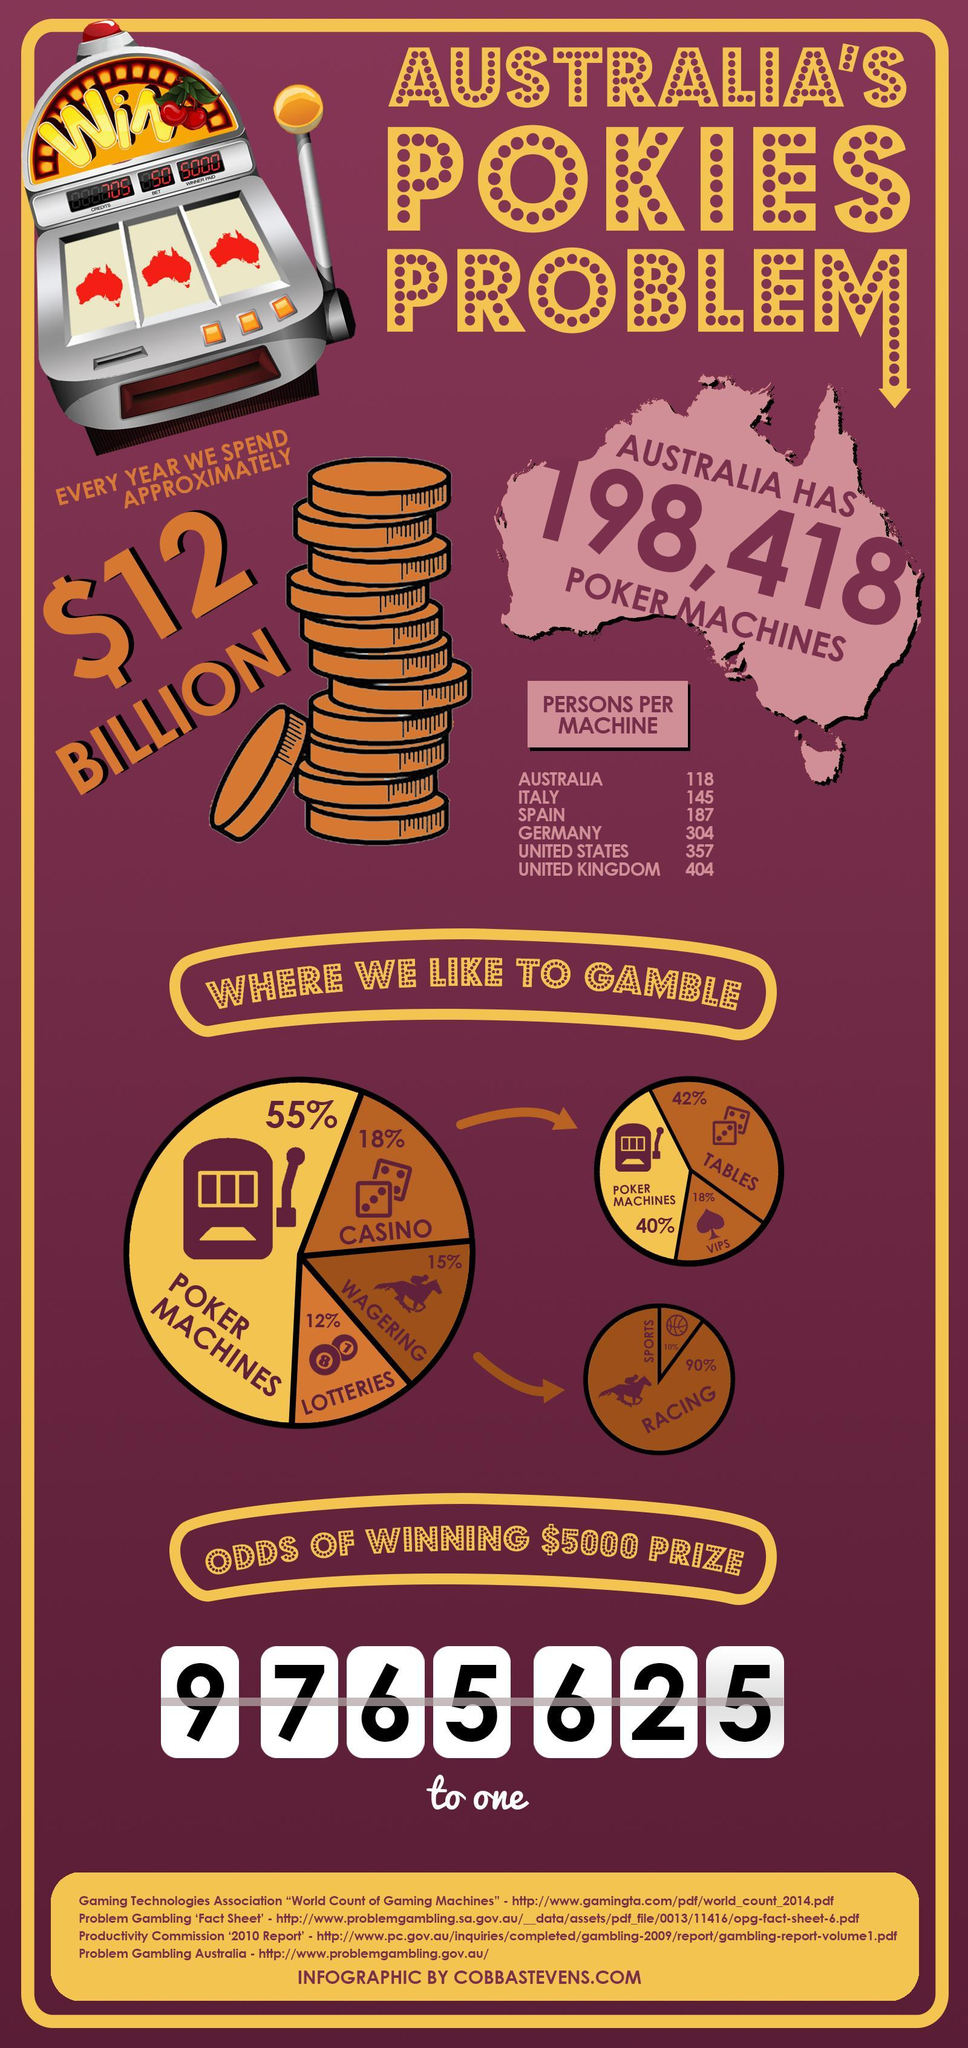Which country is listed third on the list of number of persons per poker machines?
Answer the question with a short phrase. Spain Where does most of Australia like to gamble, Casinos, Lotteries or Poker Machines? Poker Machines What is written on the poker machine ? Win Which is the second highest value listed in the table persons per machine? 357 What is the percentage difference in people using Poker machines and Casinos? 37% 